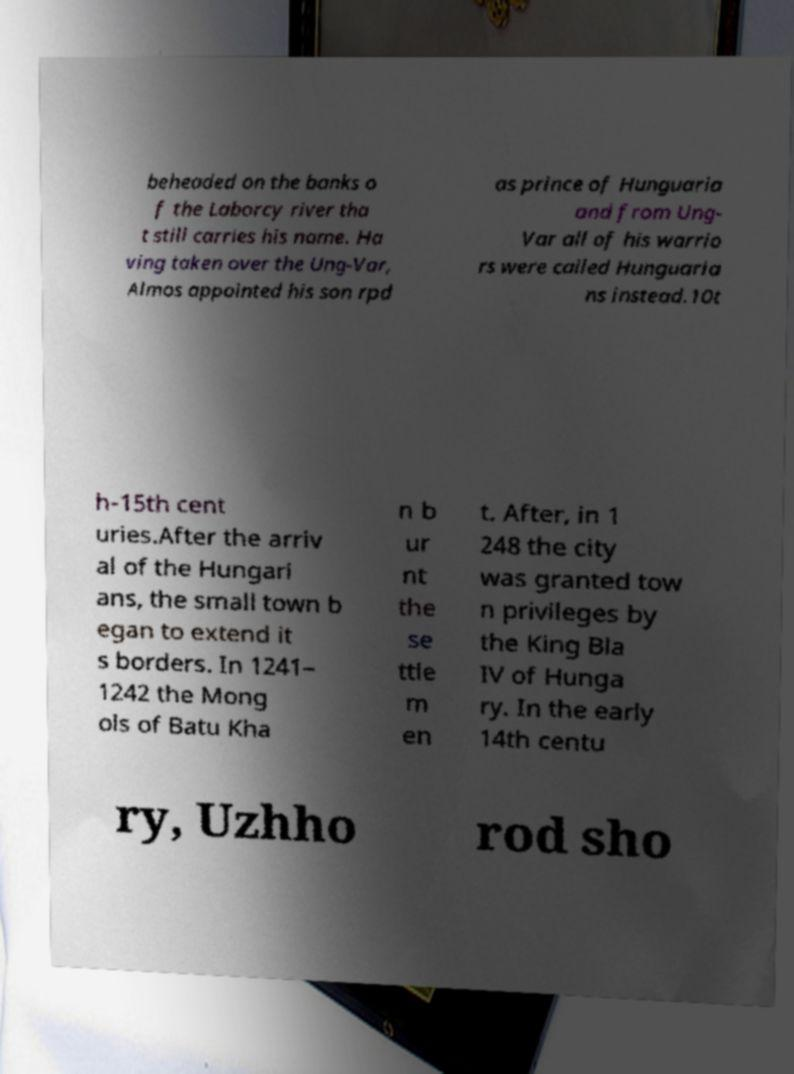What messages or text are displayed in this image? I need them in a readable, typed format. beheaded on the banks o f the Laborcy river tha t still carries his name. Ha ving taken over the Ung-Var, Almos appointed his son rpd as prince of Hunguaria and from Ung- Var all of his warrio rs were called Hunguaria ns instead.10t h-15th cent uries.After the arriv al of the Hungari ans, the small town b egan to extend it s borders. In 1241– 1242 the Mong ols of Batu Kha n b ur nt the se ttle m en t. After, in 1 248 the city was granted tow n privileges by the King Bla IV of Hunga ry. In the early 14th centu ry, Uzhho rod sho 